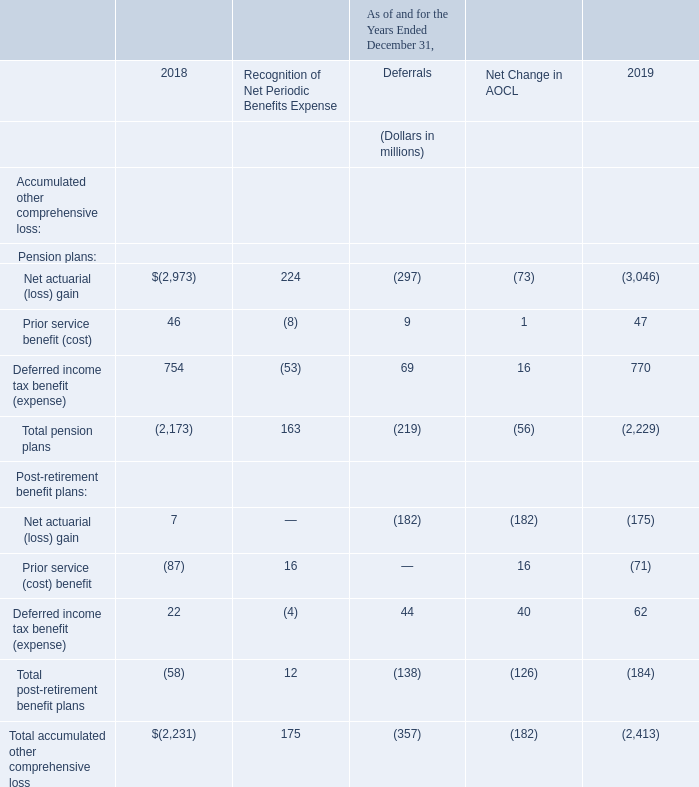Accumulated Other Comprehensive Loss-Recognition and Deferrals
The following table presents cumulative items not recognized as a component of net periodic benefits expense as of December 31, 2018, items recognized as a component of net periodic benefits expense in 2019, additional items deferred during 2019 and cumulative items not recognized as a component of net periodic benefits expense as of December 31, 2019. The items not recognized as a component of net periodic benefits expense have been recorded on our consolidated balance sheets in accumulated other comprehensive loss:
Where are the items not recognized as a component of net periodic benefits expense recorded? On our consolidated balance sheets in accumulated other comprehensive loss. The table presents cumulative items not recognized as a component of net periodic benefits expense as of which years? 2018, 2019. What is the Net actuarial (loss) gain for 2019?
Answer scale should be: million. (3,046). Which year has a larger prior service benefit (cost) under pension plans? 46<47
Answer: 2019. What is the change in the deferred income tax benefit (expense) for pension plans in 2019 from 2018?
Answer scale should be: million. 770-754
Answer: 16. What is the percentage change in the deferred income tax benefit (expense) for pension plans in 2019 from 2018?
Answer scale should be: percent. (770-754)/754
Answer: 2.12. 